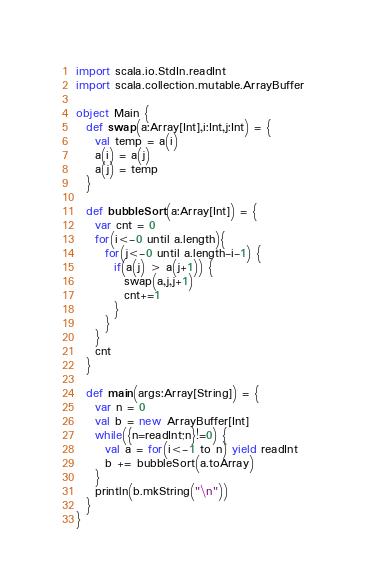<code> <loc_0><loc_0><loc_500><loc_500><_Scala_>import scala.io.StdIn.readInt
import scala.collection.mutable.ArrayBuffer

object Main {
  def swap(a:Array[Int],i:Int,j:Int) = {
    val temp = a(i)
    a(i) = a(j)
    a(j) = temp
  }

  def bubbleSort(a:Array[Int]) = {
    var cnt = 0
    for(i<-0 until a.length){
      for(j<-0 until a.length-i-1) {
        if(a(j) > a(j+1)) {
          swap(a,j,j+1)
          cnt+=1
        }
      }
    }
    cnt
  }

  def main(args:Array[String]) = {
    var n = 0
    val b = new ArrayBuffer[Int]
    while({n=readInt;n}!=0) {
      val a = for(i<-1 to n) yield readInt
      b += bubbleSort(a.toArray)
    }
    println(b.mkString("\n"))
  }
}</code> 